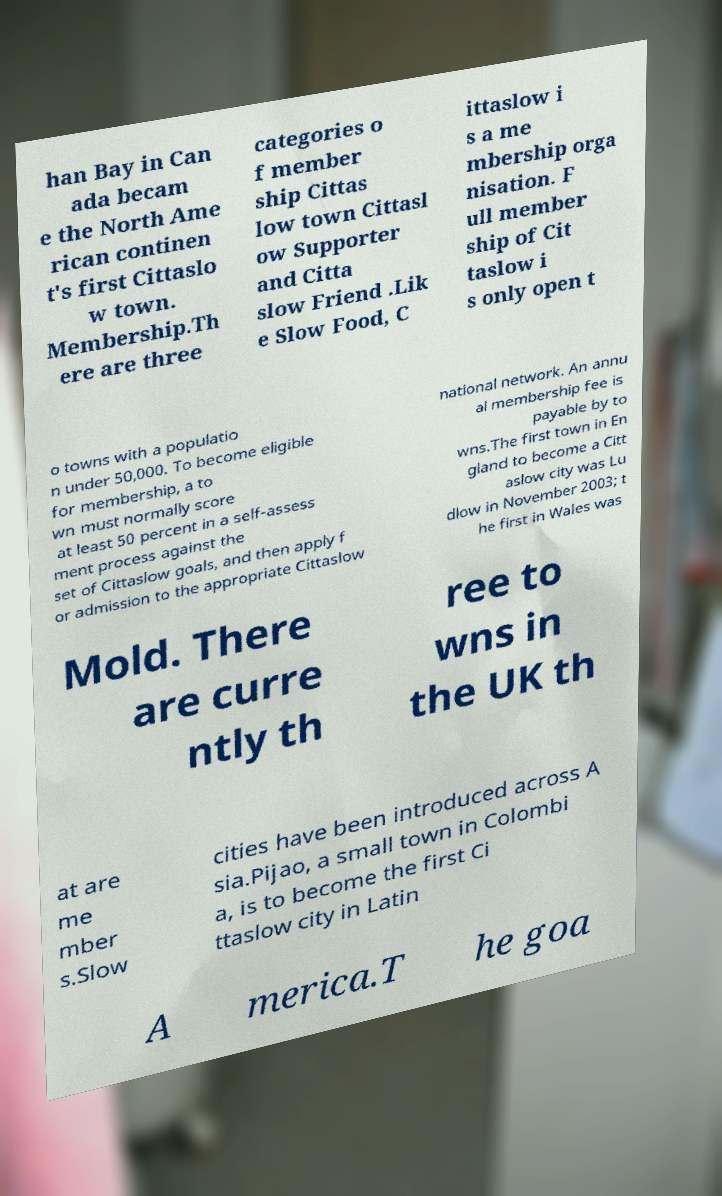Could you extract and type out the text from this image? han Bay in Can ada becam e the North Ame rican continen t's first Cittaslo w town. Membership.Th ere are three categories o f member ship Cittas low town Cittasl ow Supporter and Citta slow Friend .Lik e Slow Food, C ittaslow i s a me mbership orga nisation. F ull member ship of Cit taslow i s only open t o towns with a populatio n under 50,000. To become eligible for membership, a to wn must normally score at least 50 percent in a self-assess ment process against the set of Cittaslow goals, and then apply f or admission to the appropriate Cittaslow national network. An annu al membership fee is payable by to wns.The first town in En gland to become a Citt aslow city was Lu dlow in November 2003; t he first in Wales was Mold. There are curre ntly th ree to wns in the UK th at are me mber s.Slow cities have been introduced across A sia.Pijao, a small town in Colombi a, is to become the first Ci ttaslow city in Latin A merica.T he goa 